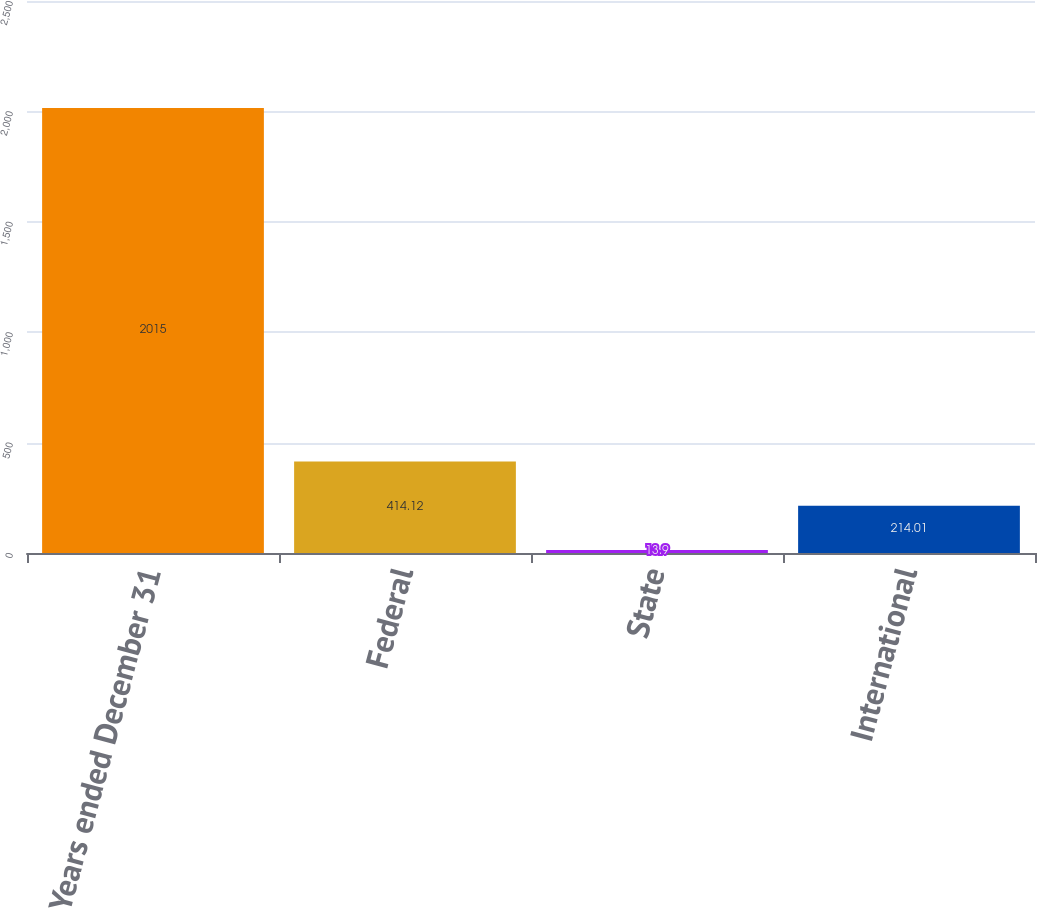Convert chart. <chart><loc_0><loc_0><loc_500><loc_500><bar_chart><fcel>Years ended December 31<fcel>Federal<fcel>State<fcel>International<nl><fcel>2015<fcel>414.12<fcel>13.9<fcel>214.01<nl></chart> 